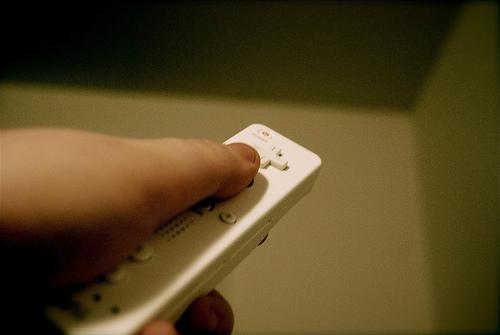Question: what is the person holding?
Choices:
A. Cellphone.
B. Gun.
C. Remote.
D. Purse.
Answer with the letter. Answer: C Question: who is holding the remote?
Choices:
A. The player.
B. The husband.
C. The lecturer.
D. The child.
Answer with the letter. Answer: A Question: what button is at the top?
Choices:
A. Power.
B. Volume.
C. Channel.
D. Record.
Answer with the letter. Answer: A 